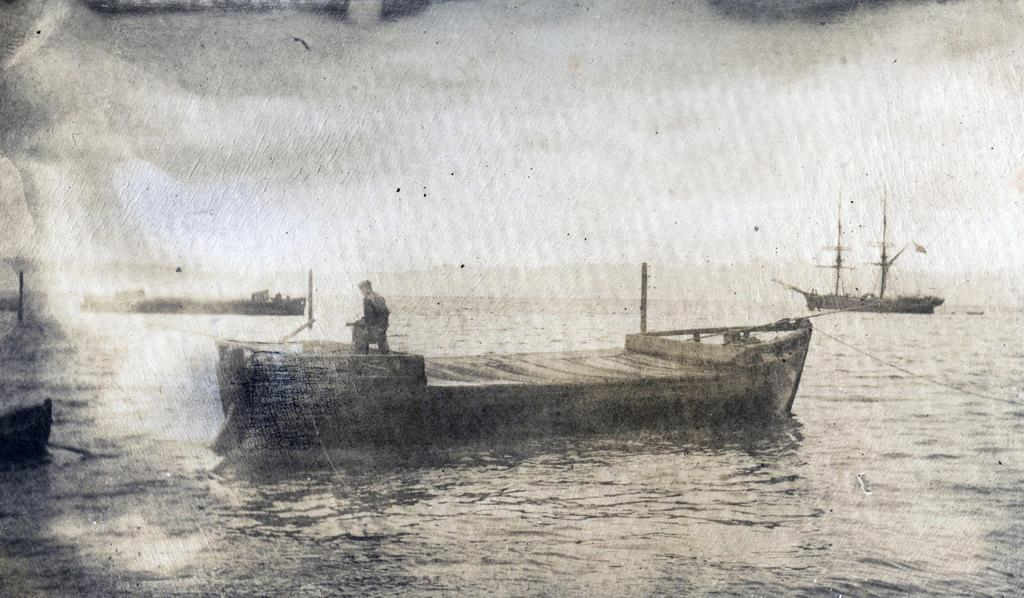What type of drawing is depicted in the image? The image is a sketch. What is the main subject of the sketch? There is a boat in the sketch. Is there anyone on the boat? Yes, there is a person standing on the boat. What can be seen in the background of the sketch? There are other boats visible in the background. What is at the bottom of the sketch? There is water at the bottom of the sketch. What type of seed is being planted by the person on the boat? There is no seed or planting activity depicted in the image; it features a person standing on a boat with other boats in the background. 